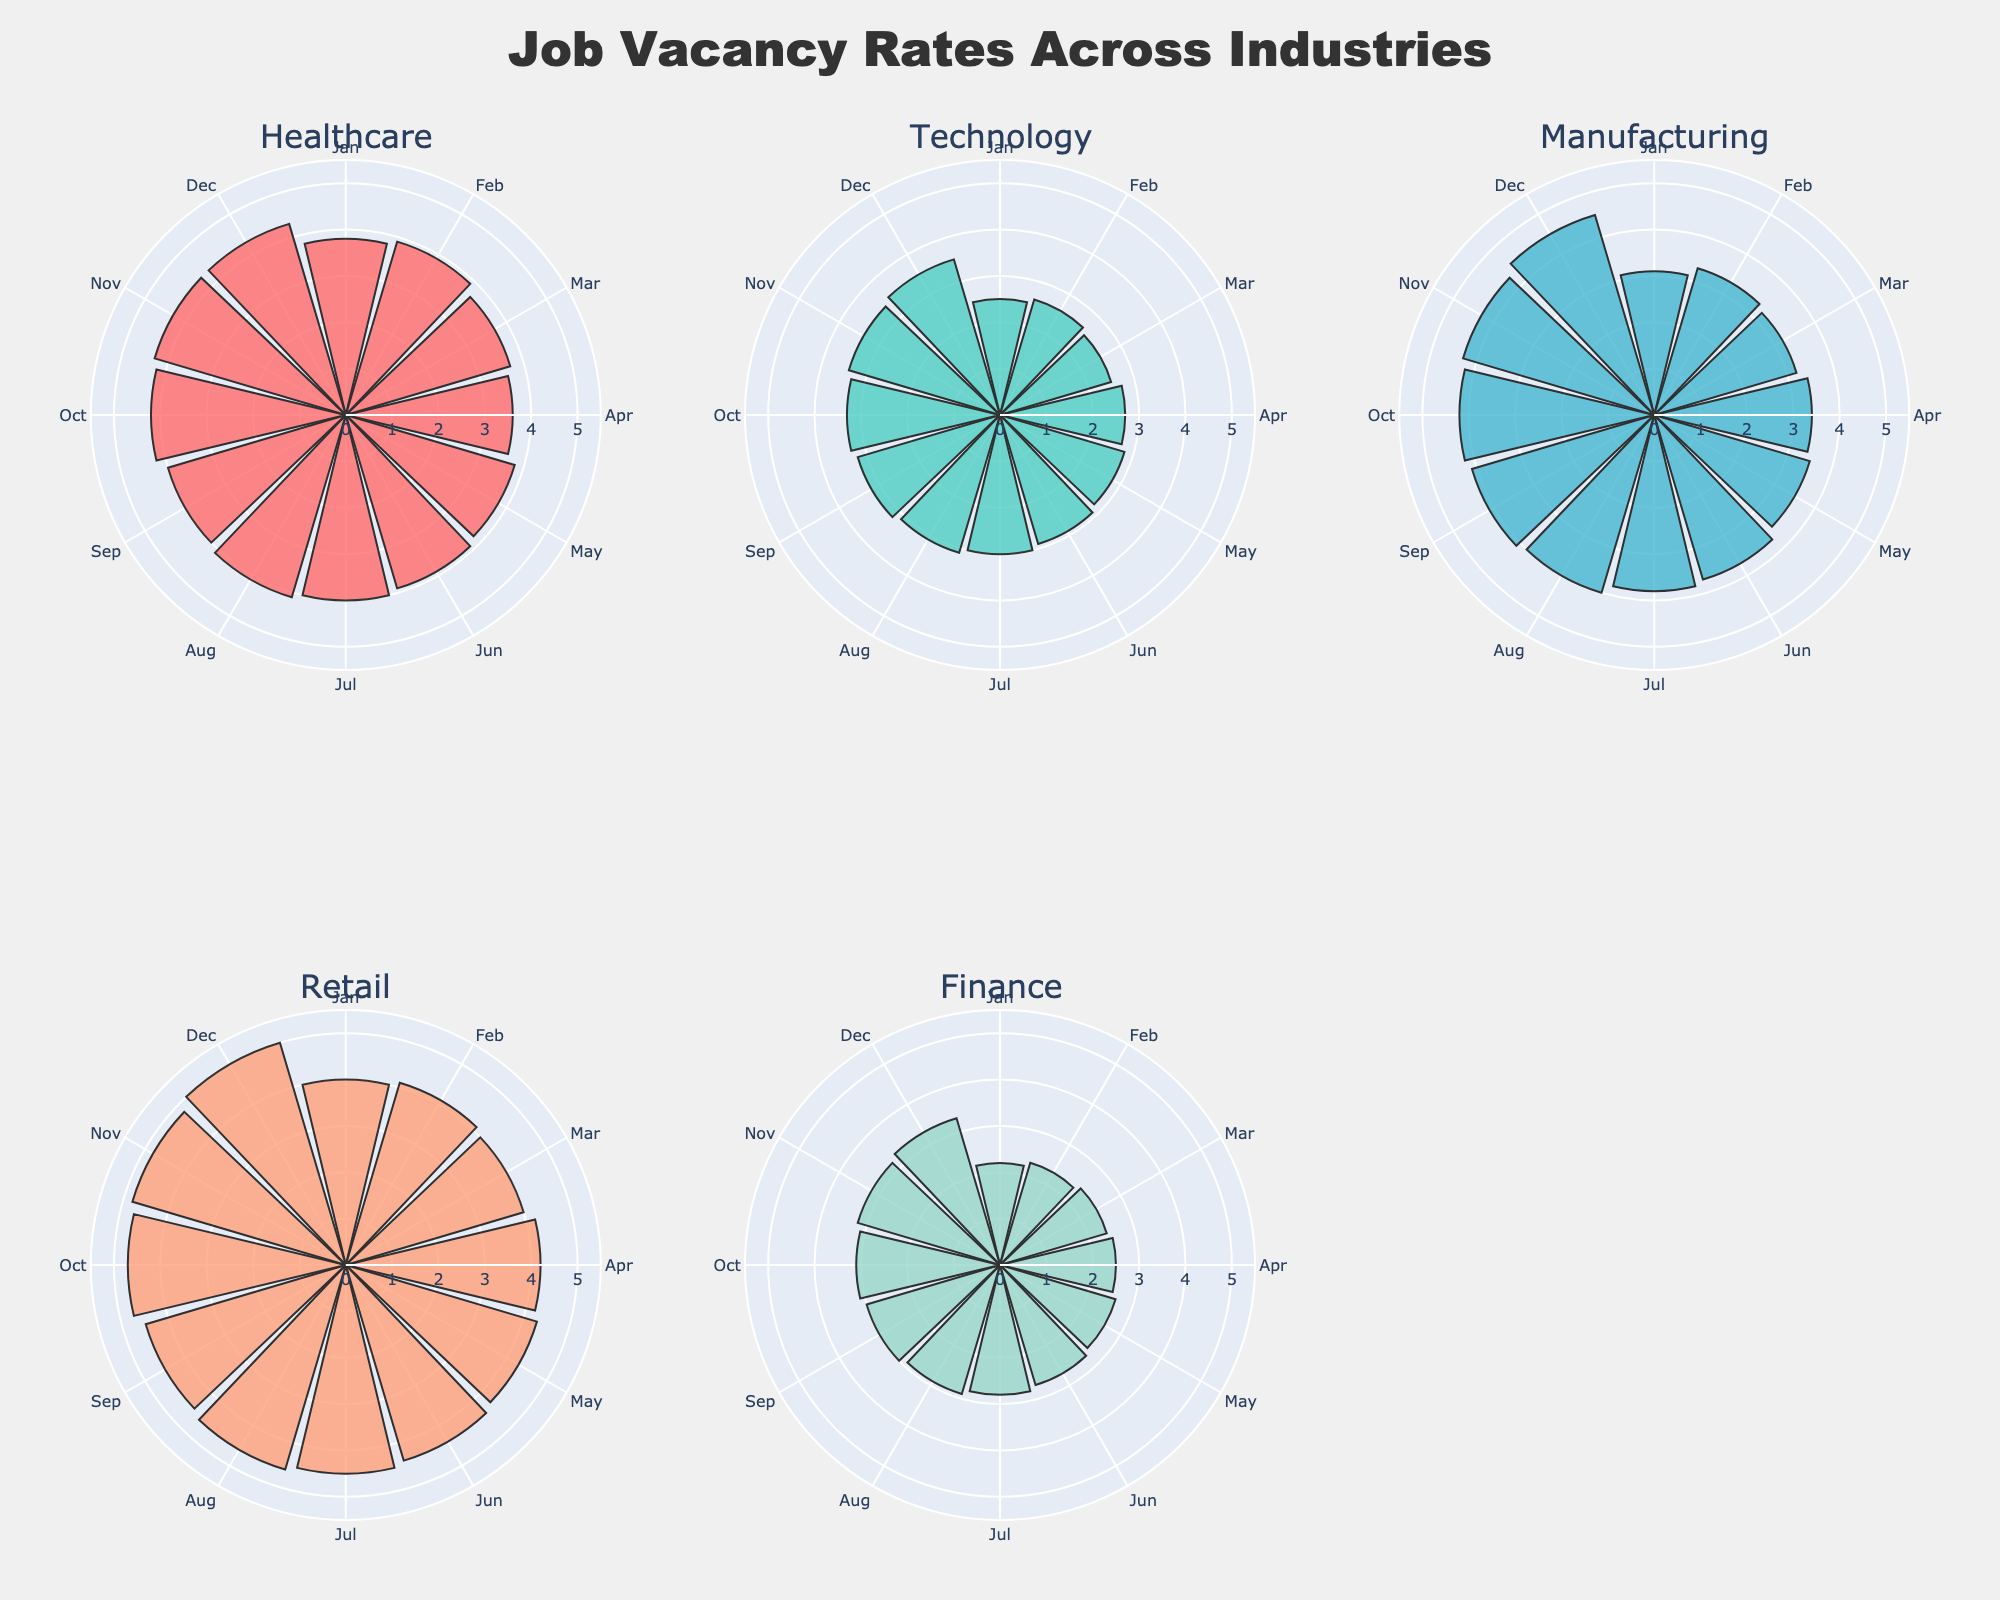What is the title of the figure? The title of the figure is centered at the top. By looking at the visual, we can determine the title.
Answer: Job Vacancy Rates Across Industries Which industry shows the highest job vacancy rate in December? In December, the retail industry shows the highest value when comparing the radial bars.
Answer: Retail What color represents the finance industry in the figure? Each industry is represented by a distinct color, and by looking at the color legend for finance, we identify it.
Answer: #98D8C8 What is the job vacancy rate for technology in July? By looking at the radial bar for technology in July, we can determine the value shown.
Answer: 3.0% Which two industries have the highest job vacancy rate in November, and what are their values? By comparing the radial bars for all industries in November, we identify the two with the highest values.
Answer: Manufacturing (4.3%) and Retail (4.8%) What is the range of job vacancy rates shown on the radial axis for each subplot? By observing the radial axis in any subplot, we can determine the range.
Answer: 0 to 5.5% Which industry experienced the most significant increase in job vacancy rates from January to December? By comparing the difference in job vacancy rates from January to December for each industry, we identify the largest increase.
Answer: Retail What is the average job vacancy rate for the healthcare industry across the year? Sum the job vacancy rates for all months in the healthcare industry and divide by 12 to find the average. January (3.8) + February (3.9) + March (3.7) + April (3.6) + May (3.8) + June (3.9) + July (4.0) + August (4.1) + September (4.0) + October (4.2) + November (4.3) + December (4.3) = 47.6. Average = 47.6/12.
Answer: 3.97% Which month observes the highest job vacancy rate across all industries? By identifying the month where the circle radius (job vacancy rate) is the largest, we determine this.
Answer: December Compare the job vacancy rates between manufacturing and technology industries in September. Which one is higher and by how much? By identifying the values for September in both industries and subtracting the smaller from the larger, we determine the difference. Manufacturing (4.1) - Technology (3.2) = 0.9.
Answer: Manufacturing is higher by 0.9% Explain the general trend in job vacancy rates for the finance industry from January to December. By tracing the radial bars for each month in the finance industry subplot and noting changes, we observe the trend. The rate increases steadily each month.
Answer: Steady Increase 